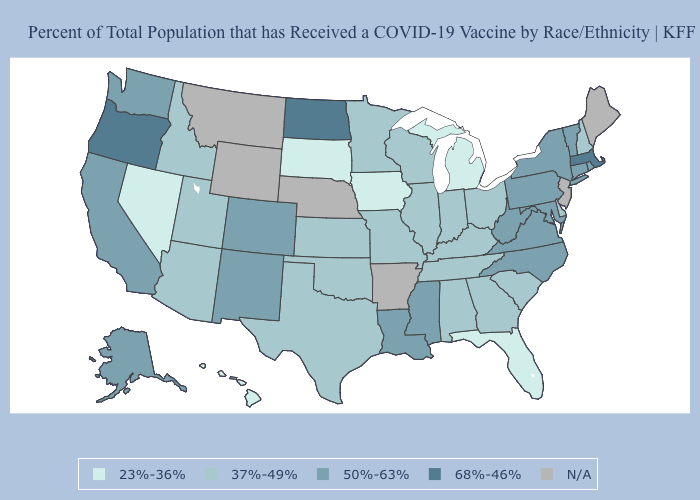Which states have the highest value in the USA?
Keep it brief. Massachusetts, North Dakota, Oregon. Name the states that have a value in the range N/A?
Keep it brief. Arkansas, Maine, Montana, Nebraska, New Jersey, Wyoming. Does the first symbol in the legend represent the smallest category?
Answer briefly. Yes. Name the states that have a value in the range 68%-46%?
Short answer required. Massachusetts, North Dakota, Oregon. Among the states that border New Hampshire , which have the lowest value?
Write a very short answer. Vermont. Name the states that have a value in the range N/A?
Short answer required. Arkansas, Maine, Montana, Nebraska, New Jersey, Wyoming. Which states have the lowest value in the Northeast?
Keep it brief. New Hampshire. What is the highest value in the USA?
Keep it brief. 68%-46%. What is the value of Connecticut?
Concise answer only. 50%-63%. Which states have the lowest value in the USA?
Concise answer only. Florida, Hawaii, Iowa, Michigan, Nevada, South Dakota. Is the legend a continuous bar?
Quick response, please. No. Which states have the lowest value in the West?
Answer briefly. Hawaii, Nevada. Name the states that have a value in the range 50%-63%?
Write a very short answer. Alaska, California, Colorado, Connecticut, Louisiana, Maryland, Mississippi, New Mexico, New York, North Carolina, Pennsylvania, Rhode Island, Vermont, Virginia, Washington, West Virginia. What is the value of Oklahoma?
Write a very short answer. 37%-49%. 